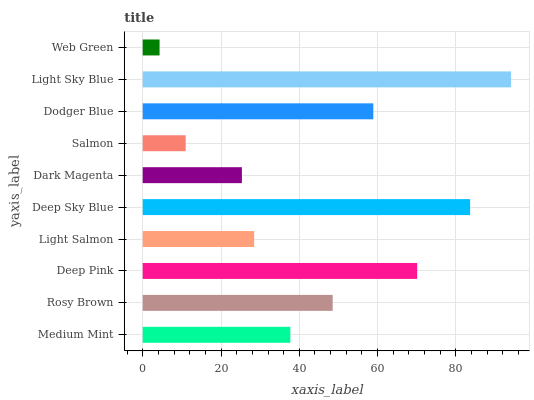Is Web Green the minimum?
Answer yes or no. Yes. Is Light Sky Blue the maximum?
Answer yes or no. Yes. Is Rosy Brown the minimum?
Answer yes or no. No. Is Rosy Brown the maximum?
Answer yes or no. No. Is Rosy Brown greater than Medium Mint?
Answer yes or no. Yes. Is Medium Mint less than Rosy Brown?
Answer yes or no. Yes. Is Medium Mint greater than Rosy Brown?
Answer yes or no. No. Is Rosy Brown less than Medium Mint?
Answer yes or no. No. Is Rosy Brown the high median?
Answer yes or no. Yes. Is Medium Mint the low median?
Answer yes or no. Yes. Is Light Sky Blue the high median?
Answer yes or no. No. Is Light Sky Blue the low median?
Answer yes or no. No. 